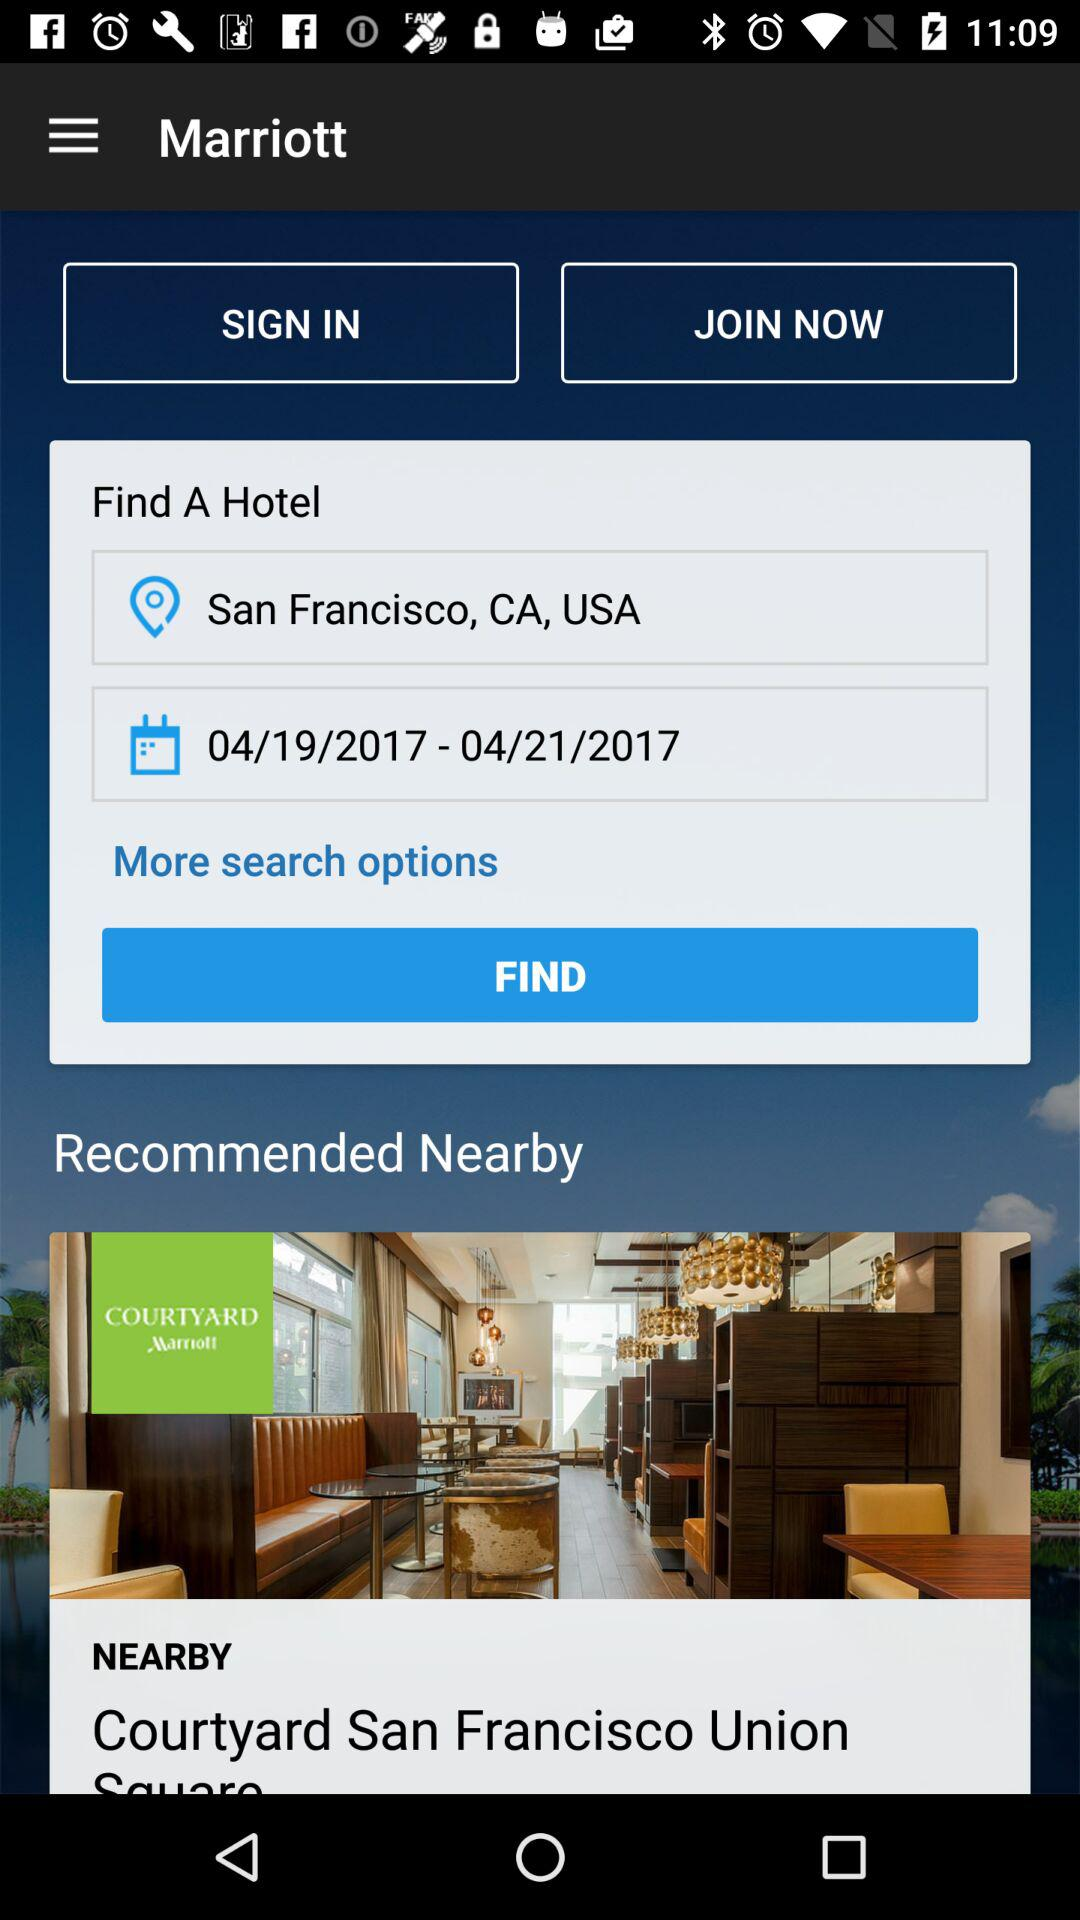What is the selected location? The selected location is San Francisco, CA, USA. 